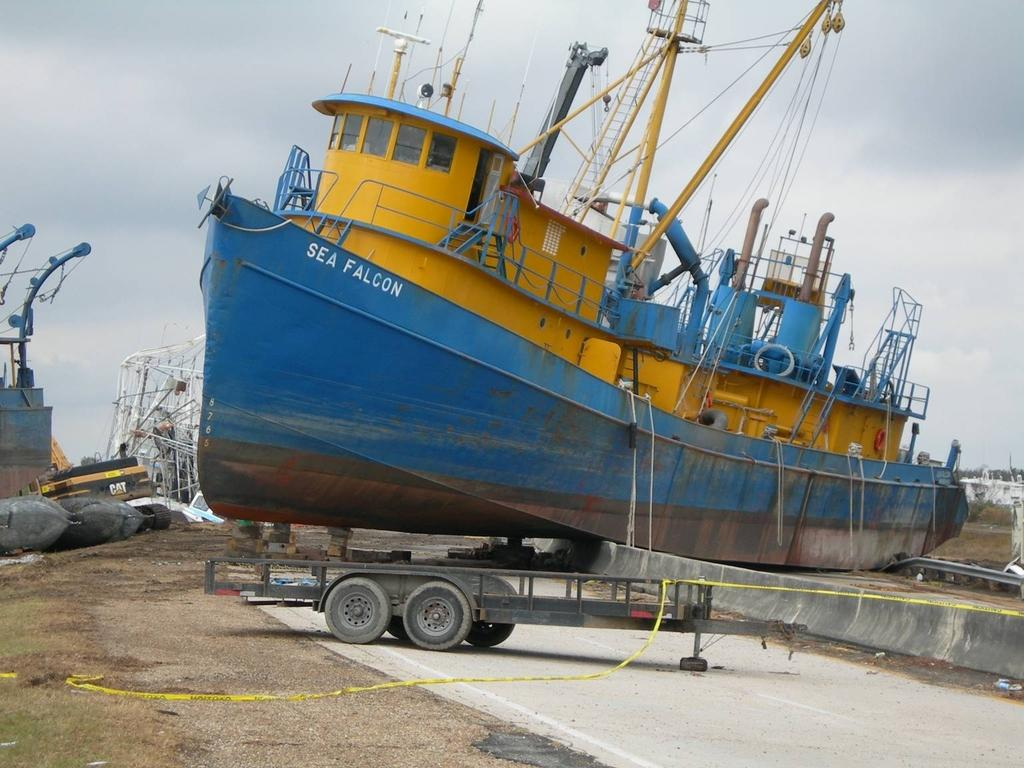<image>
Write a terse but informative summary of the picture. A blue and yellow ship called the Sea Falcon is parked on land. 